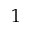Convert formula to latex. <formula><loc_0><loc_0><loc_500><loc_500>1</formula> 